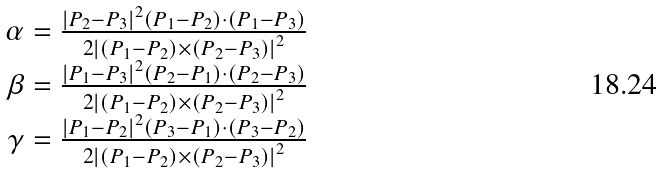<formula> <loc_0><loc_0><loc_500><loc_500>\begin{array} { r } { \alpha = { \frac { \left | P _ { 2 } - P _ { 3 } \right | ^ { 2 } \left ( P _ { 1 } - P _ { 2 } \right ) \cdot \left ( P _ { 1 } - P _ { 3 } \right ) } { 2 \left | \left ( P _ { 1 } - P _ { 2 } \right ) \times \left ( P _ { 2 } - P _ { 3 } \right ) \right | ^ { 2 } } } } \\ { \beta = { \frac { \left | P _ { 1 } - P _ { 3 } \right | ^ { 2 } \left ( P _ { 2 } - P _ { 1 } \right ) \cdot \left ( P _ { 2 } - P _ { 3 } \right ) } { 2 \left | \left ( P _ { 1 } - P _ { 2 } \right ) \times \left ( P _ { 2 } - P _ { 3 } \right ) \right | ^ { 2 } } } } \\ { \gamma = { \frac { \left | P _ { 1 } - P _ { 2 } \right | ^ { 2 } \left ( P _ { 3 } - P _ { 1 } \right ) \cdot \left ( P _ { 3 } - P _ { 2 } \right ) } { 2 \left | \left ( P _ { 1 } - P _ { 2 } \right ) \times \left ( P _ { 2 } - P _ { 3 } \right ) \right | ^ { 2 } } } } \end{array}</formula> 